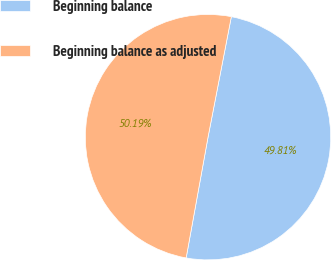Convert chart to OTSL. <chart><loc_0><loc_0><loc_500><loc_500><pie_chart><fcel>Beginning balance<fcel>Beginning balance as adjusted<nl><fcel>49.81%<fcel>50.19%<nl></chart> 